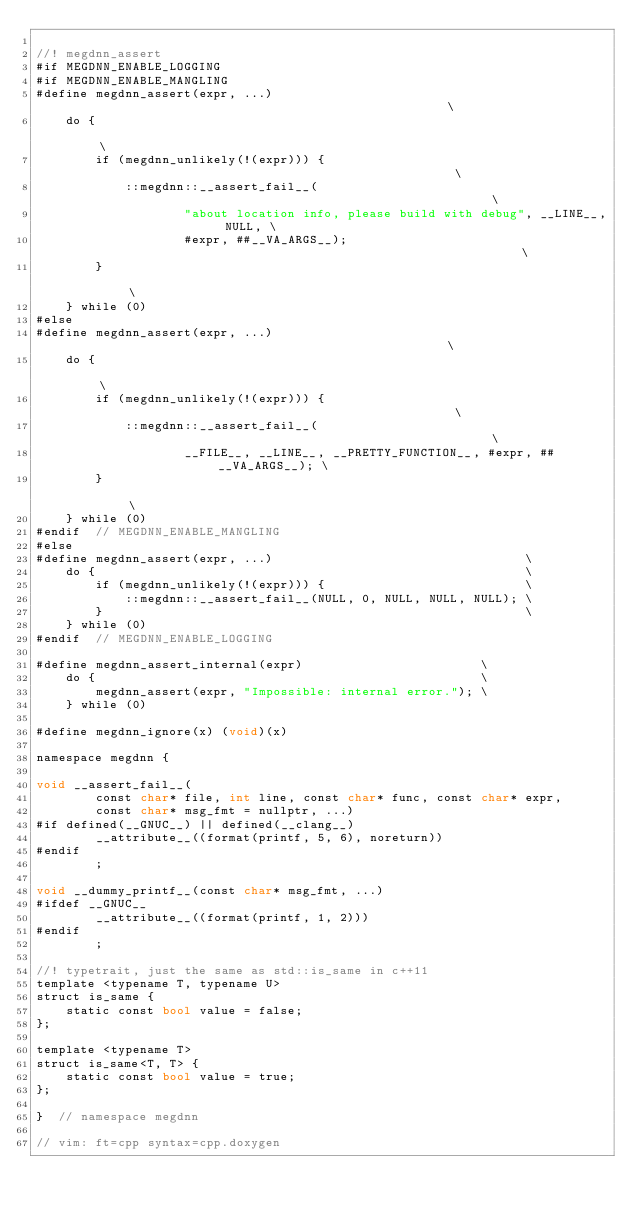Convert code to text. <code><loc_0><loc_0><loc_500><loc_500><_Cuda_>
//! megdnn_assert
#if MEGDNN_ENABLE_LOGGING
#if MEGDNN_ENABLE_MANGLING
#define megdnn_assert(expr, ...)                                                    \
    do {                                                                            \
        if (megdnn_unlikely(!(expr))) {                                             \
            ::megdnn::__assert_fail__(                                              \
                    "about location info, please build with debug", __LINE__, NULL, \
                    #expr, ##__VA_ARGS__);                                          \
        }                                                                           \
    } while (0)
#else
#define megdnn_assert(expr, ...)                                                    \
    do {                                                                            \
        if (megdnn_unlikely(!(expr))) {                                             \
            ::megdnn::__assert_fail__(                                              \
                    __FILE__, __LINE__, __PRETTY_FUNCTION__, #expr, ##__VA_ARGS__); \
        }                                                                           \
    } while (0)
#endif  // MEGDNN_ENABLE_MANGLING
#else
#define megdnn_assert(expr, ...)                                  \
    do {                                                          \
        if (megdnn_unlikely(!(expr))) {                           \
            ::megdnn::__assert_fail__(NULL, 0, NULL, NULL, NULL); \
        }                                                         \
    } while (0)
#endif  // MEGDNN_ENABLE_LOGGING

#define megdnn_assert_internal(expr)                        \
    do {                                                    \
        megdnn_assert(expr, "Impossible: internal error."); \
    } while (0)

#define megdnn_ignore(x) (void)(x)

namespace megdnn {

void __assert_fail__(
        const char* file, int line, const char* func, const char* expr,
        const char* msg_fmt = nullptr, ...)
#if defined(__GNUC__) || defined(__clang__)
        __attribute__((format(printf, 5, 6), noreturn))
#endif
        ;

void __dummy_printf__(const char* msg_fmt, ...)
#ifdef __GNUC__
        __attribute__((format(printf, 1, 2)))
#endif
        ;

//! typetrait, just the same as std::is_same in c++11
template <typename T, typename U>
struct is_same {
    static const bool value = false;
};

template <typename T>
struct is_same<T, T> {
    static const bool value = true;
};

}  // namespace megdnn

// vim: ft=cpp syntax=cpp.doxygen
</code> 